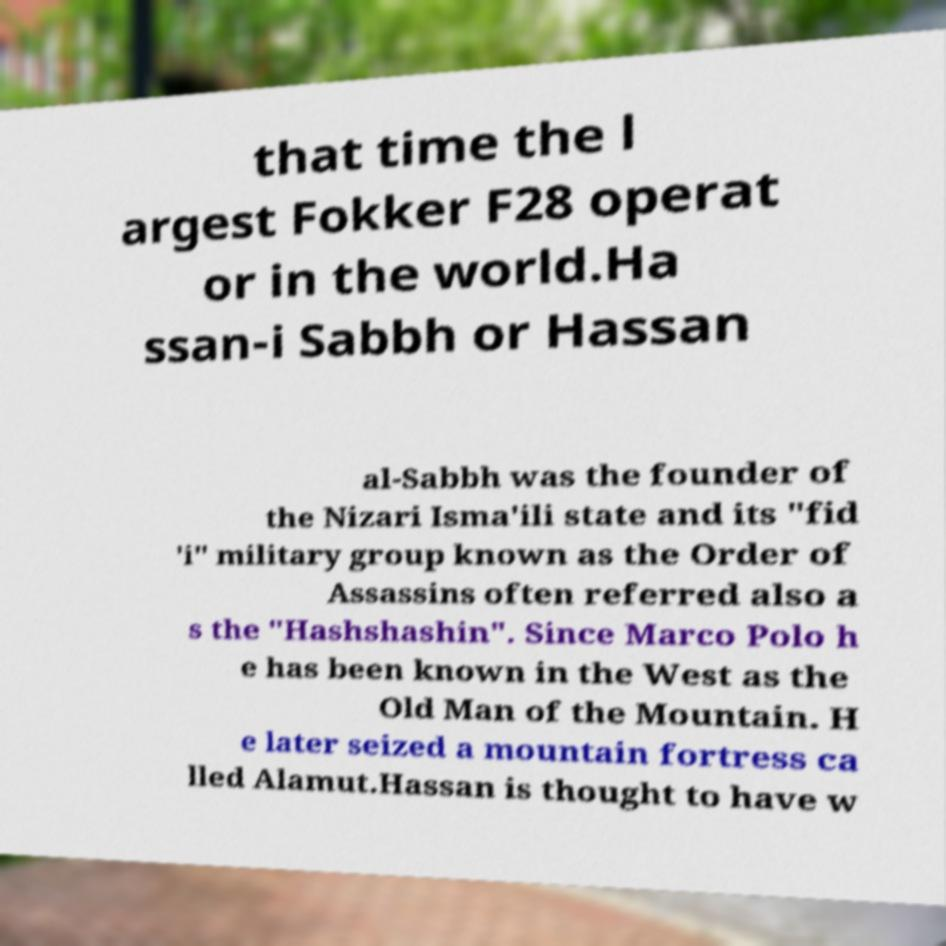Please read and relay the text visible in this image. What does it say? that time the l argest Fokker F28 operat or in the world.Ha ssan-i Sabbh or Hassan al-Sabbh was the founder of the Nizari Isma'ili state and its "fid 'i" military group known as the Order of Assassins often referred also a s the "Hashshashin". Since Marco Polo h e has been known in the West as the Old Man of the Mountain. H e later seized a mountain fortress ca lled Alamut.Hassan is thought to have w 